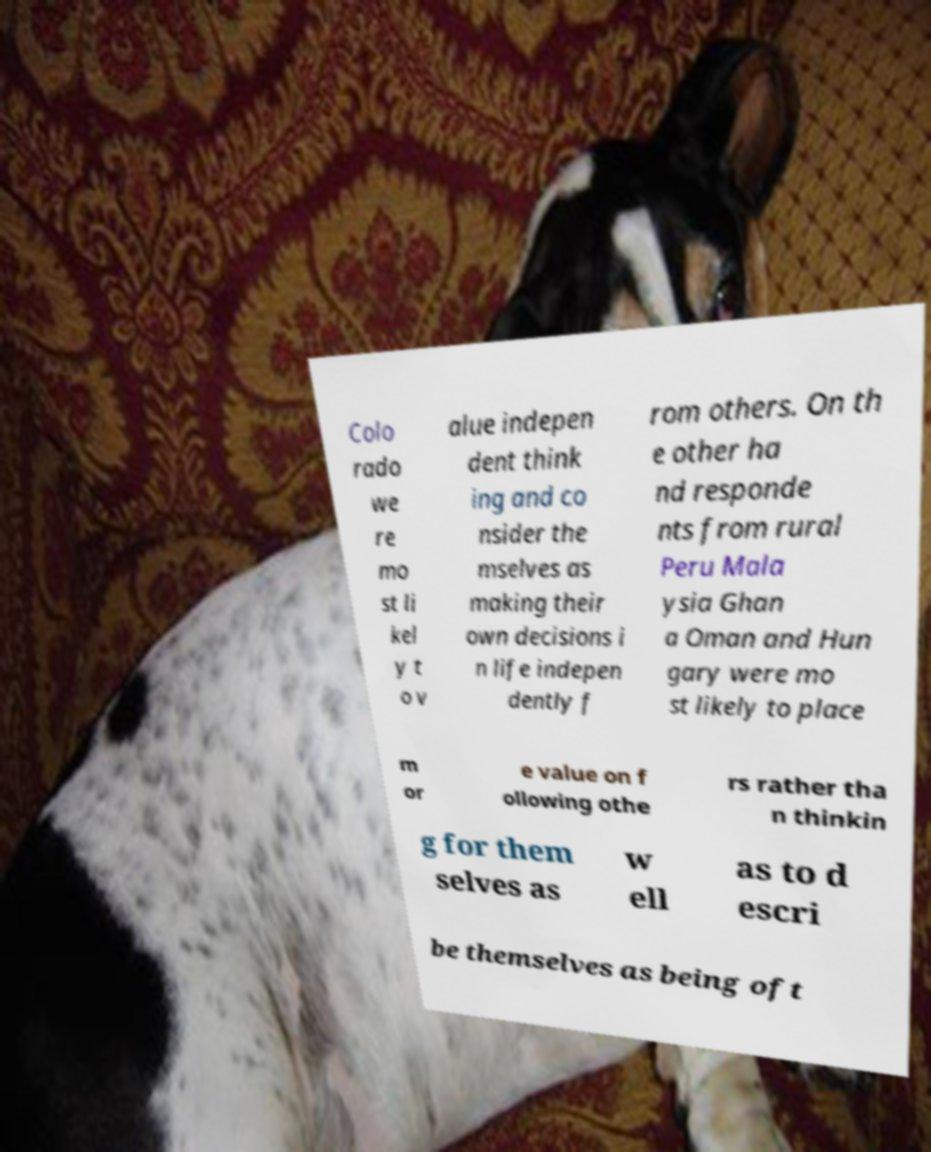What messages or text are displayed in this image? I need them in a readable, typed format. Colo rado we re mo st li kel y t o v alue indepen dent think ing and co nsider the mselves as making their own decisions i n life indepen dently f rom others. On th e other ha nd responde nts from rural Peru Mala ysia Ghan a Oman and Hun gary were mo st likely to place m or e value on f ollowing othe rs rather tha n thinkin g for them selves as w ell as to d escri be themselves as being oft 